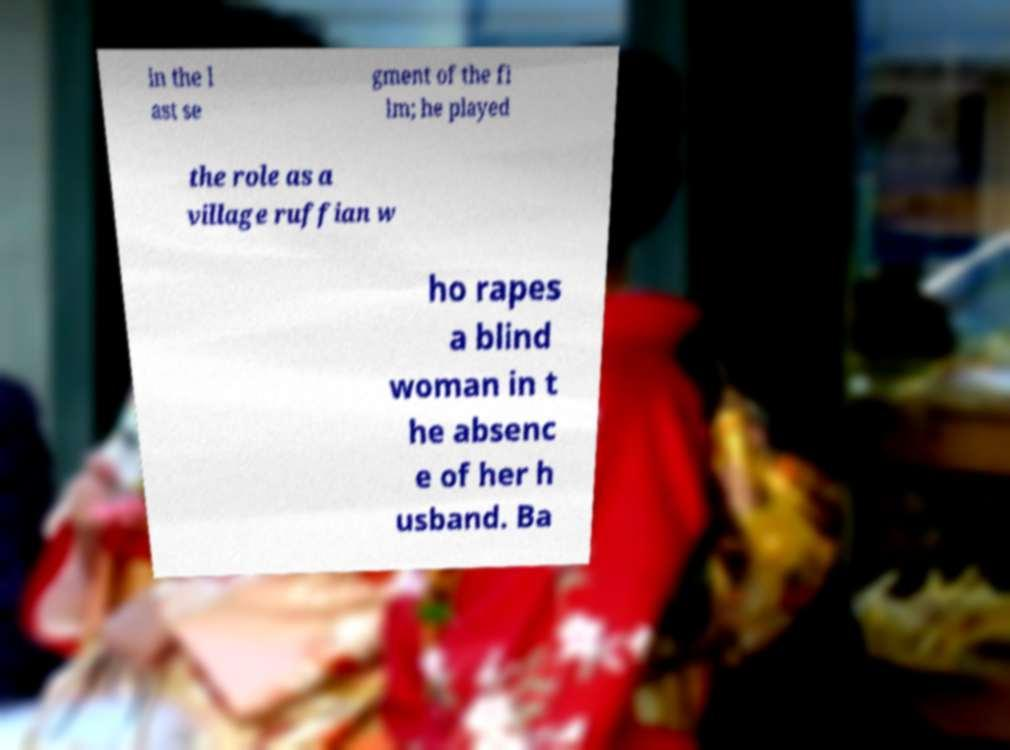Could you assist in decoding the text presented in this image and type it out clearly? in the l ast se gment of the fi lm; he played the role as a village ruffian w ho rapes a blind woman in t he absenc e of her h usband. Ba 